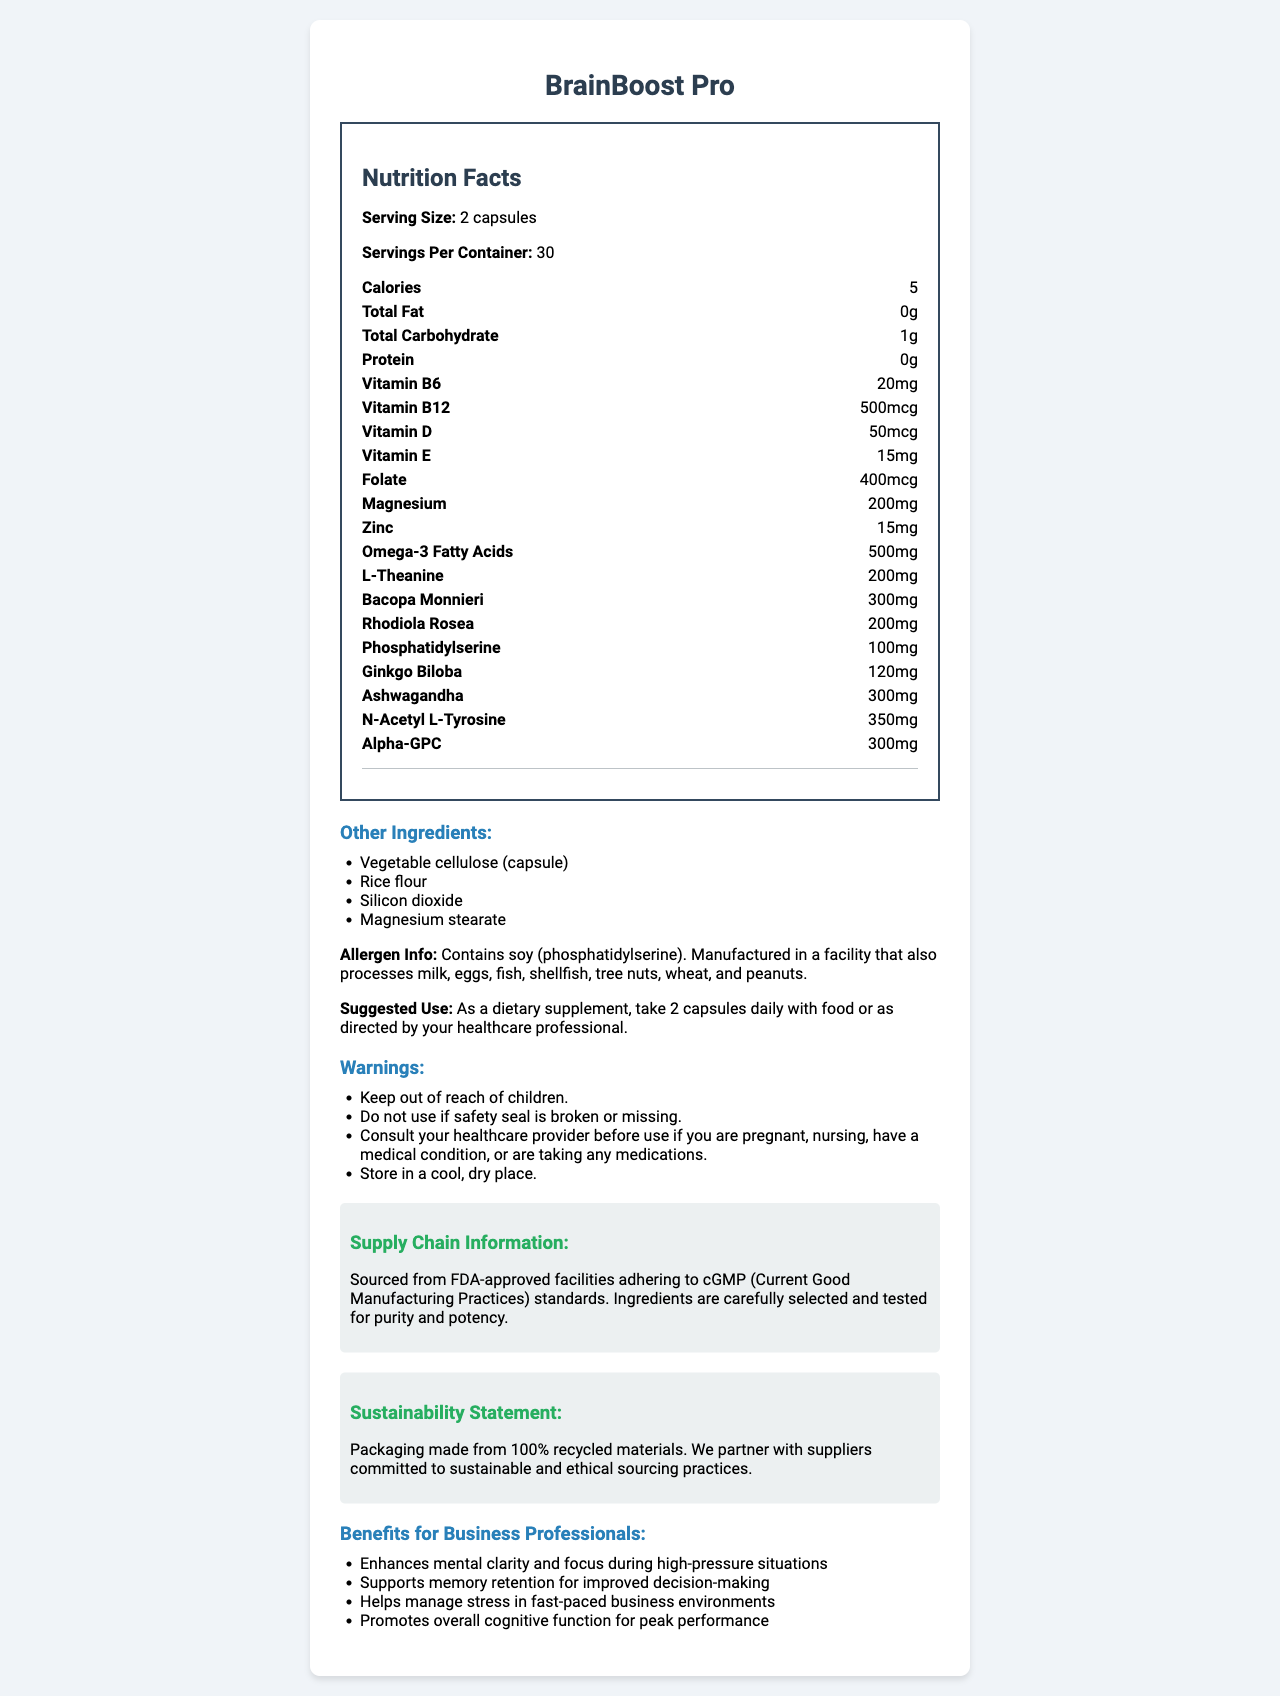what is the serving size for BrainBoost Pro? The document clearly indicates that the serving size is "2 capsules."
Answer: 2 capsules how many servings are there per container? The document states that there are 30 servings per container.
Answer: 30 what are the calories per serving? The nutrition label specifies that each serving contains 5 calories.
Answer: 5 calories does BrainBoost Pro contain any protein? The nutrition facts list shows "Protein: 0g," indicating that there is no protein in this supplement.
Answer: No what is the amount of Vitamin B12 per serving? The document states that each serving contains 500mcg of Vitamin B12.
Answer: 500mcg which vitamin is provided at a 50mcg dosage per serving? A. Vitamin B6 B. Vitamin B12 C. Vitamin D D. Vitamin E The nutrition facts show that Vitamin D is provided at 50mcg per serving.
Answer: C. Vitamin D how many milligrams of Zinc does BrainBoost Pro contain per serving? A. 15mg B. 200mg C. 300mg D. 120mg The document lists the Zinc content as 15mg per serving.
Answer: A. 15mg is BrainBoost Pro free from allergens? The allergen information states that it contains soy (phosphatidylserine) and is manufactured in a facility that processes various allergens like milk, eggs, and nuts.
Answer: No are the ingredients in BrainBoost Pro sourced sustainably? The sustainability statement says that the packaging is made from 100% recycled materials and that they partner with suppliers committed to sustainable and ethical sourcing practices.
Answer: Yes describe the main benefits of BrainBoost Pro for business professionals. The benefits for business professionals listed include enhanced mental clarity, support for memory retention, stress management, and overall cognitive function improvement.
Answer: Enhances mental clarity, supports memory retention, helps manage stress, promotes overall cognitive function is BrainBoost Pro suitable for vegetarians? The information about the ingredients does not specify whether they are all vegetarian-friendly, and it only mentions some ingredients as being vegetable cellulose and rice flour.
Answer: Cannot be determined what are the main components of the suggested use section? The suggested use section advises to take 2 capsules daily with food or as directed by a healthcare professional.
Answer: Take 2 capsules daily with food or as directed by your healthcare professional summarize the entire document. The document provides a comprehensive overview of the BrainBoost Pro supplement, including its nutritional content, serving size, allergen info, ingredients, suggested use, warnings, supply chain info, sustainability statement, and its benefits tailored for business professionals.
Answer: BrainBoost Pro is a vitamin supplement designed to enhance cognitive function and manage stress for business professionals. The product contains a variety of vitamins, minerals, and herbal ingredients. It has a serving size of 2 capsules and provides a range of nutrients per serving. The packaging is sustainable, and the product is sourced from FDA-approved facilities. Specific benefits for business professionals include mental clarity, memory support, stress management, and overall cognitive function. 